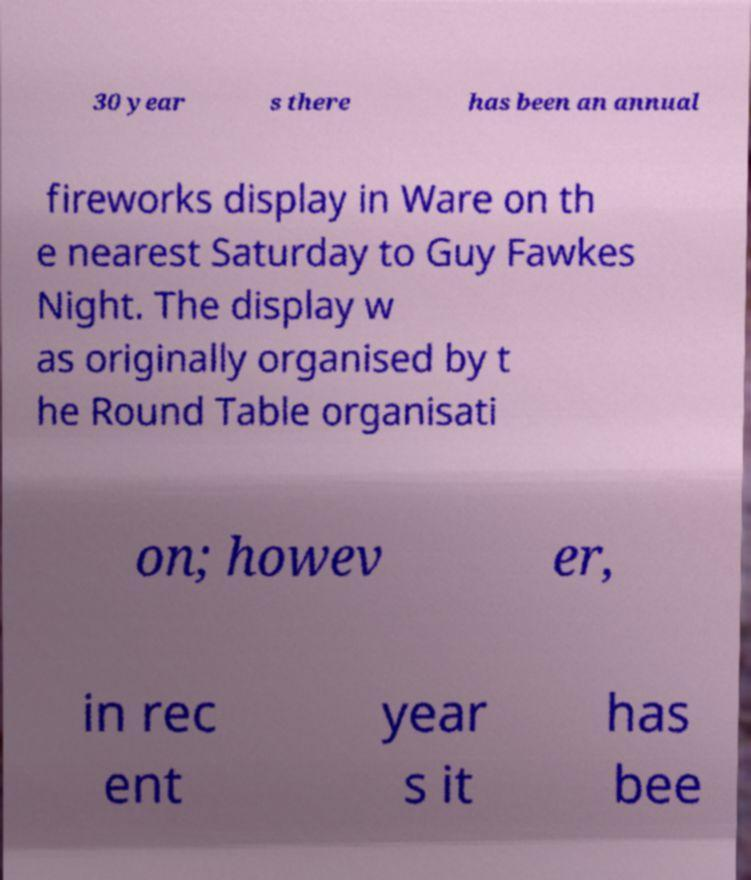Can you accurately transcribe the text from the provided image for me? 30 year s there has been an annual fireworks display in Ware on th e nearest Saturday to Guy Fawkes Night. The display w as originally organised by t he Round Table organisati on; howev er, in rec ent year s it has bee 